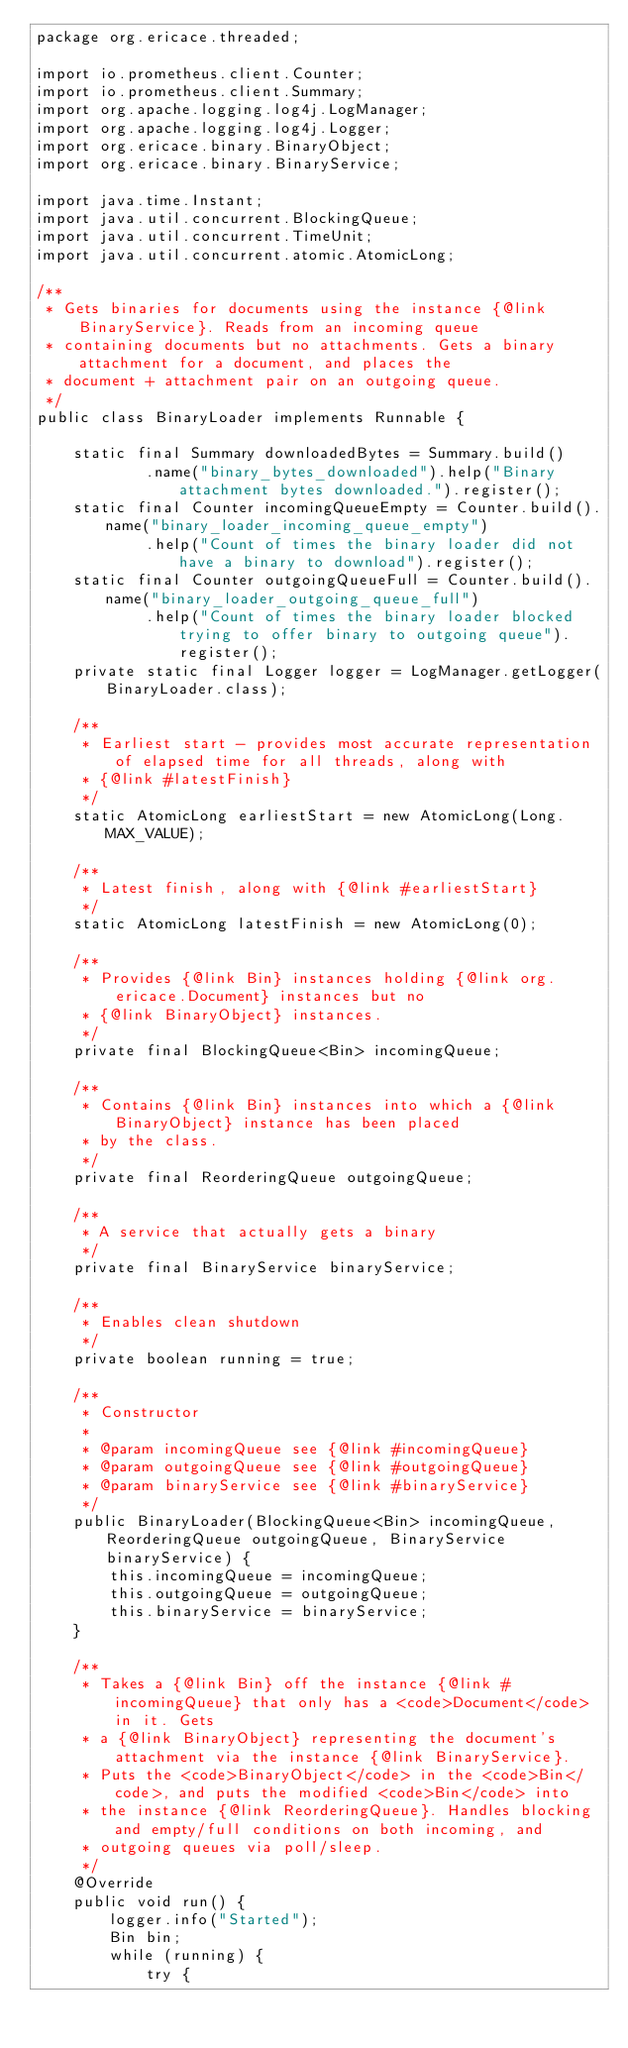<code> <loc_0><loc_0><loc_500><loc_500><_Java_>package org.ericace.threaded;

import io.prometheus.client.Counter;
import io.prometheus.client.Summary;
import org.apache.logging.log4j.LogManager;
import org.apache.logging.log4j.Logger;
import org.ericace.binary.BinaryObject;
import org.ericace.binary.BinaryService;

import java.time.Instant;
import java.util.concurrent.BlockingQueue;
import java.util.concurrent.TimeUnit;
import java.util.concurrent.atomic.AtomicLong;

/**
 * Gets binaries for documents using the instance {@link BinaryService}. Reads from an incoming queue
 * containing documents but no attachments. Gets a binary attachment for a document, and places the
 * document + attachment pair on an outgoing queue.
 */
public class BinaryLoader implements Runnable {

    static final Summary downloadedBytes = Summary.build()
            .name("binary_bytes_downloaded").help("Binary attachment bytes downloaded.").register();
    static final Counter incomingQueueEmpty = Counter.build().name("binary_loader_incoming_queue_empty")
            .help("Count of times the binary loader did not have a binary to download").register();
    static final Counter outgoingQueueFull = Counter.build().name("binary_loader_outgoing_queue_full")
            .help("Count of times the binary loader blocked trying to offer binary to outgoing queue").register();
    private static final Logger logger = LogManager.getLogger(BinaryLoader.class);

    /**
     * Earliest start - provides most accurate representation of elapsed time for all threads, along with
     * {@link #latestFinish}
     */
    static AtomicLong earliestStart = new AtomicLong(Long.MAX_VALUE);

    /**
     * Latest finish, along with {@link #earliestStart}
     */
    static AtomicLong latestFinish = new AtomicLong(0);

    /**
     * Provides {@link Bin} instances holding {@link org.ericace.Document} instances but no
     * {@link BinaryObject} instances.
     */
    private final BlockingQueue<Bin> incomingQueue;

    /**
     * Contains {@link Bin} instances into which a {@link BinaryObject} instance has been placed
     * by the class.
     */
    private final ReorderingQueue outgoingQueue;

    /**
     * A service that actually gets a binary
     */
    private final BinaryService binaryService;

    /**
     * Enables clean shutdown
     */
    private boolean running = true;

    /**
     * Constructor
     *
     * @param incomingQueue see {@link #incomingQueue}
     * @param outgoingQueue see {@link #outgoingQueue}
     * @param binaryService see {@link #binaryService}
     */
    public BinaryLoader(BlockingQueue<Bin> incomingQueue, ReorderingQueue outgoingQueue, BinaryService binaryService) {
        this.incomingQueue = incomingQueue;
        this.outgoingQueue = outgoingQueue;
        this.binaryService = binaryService;
    }

    /**
     * Takes a {@link Bin} off the instance {@link #incomingQueue} that only has a <code>Document</code> in it. Gets
     * a {@link BinaryObject} representing the document's attachment via the instance {@link BinaryService}.
     * Puts the <code>BinaryObject</code> in the <code>Bin</code>, and puts the modified <code>Bin</code> into
     * the instance {@link ReorderingQueue}. Handles blocking and empty/full conditions on both incoming, and
     * outgoing queues via poll/sleep.
     */
    @Override
    public void run() {
        logger.info("Started");
        Bin bin;
        while (running) {
            try {</code> 